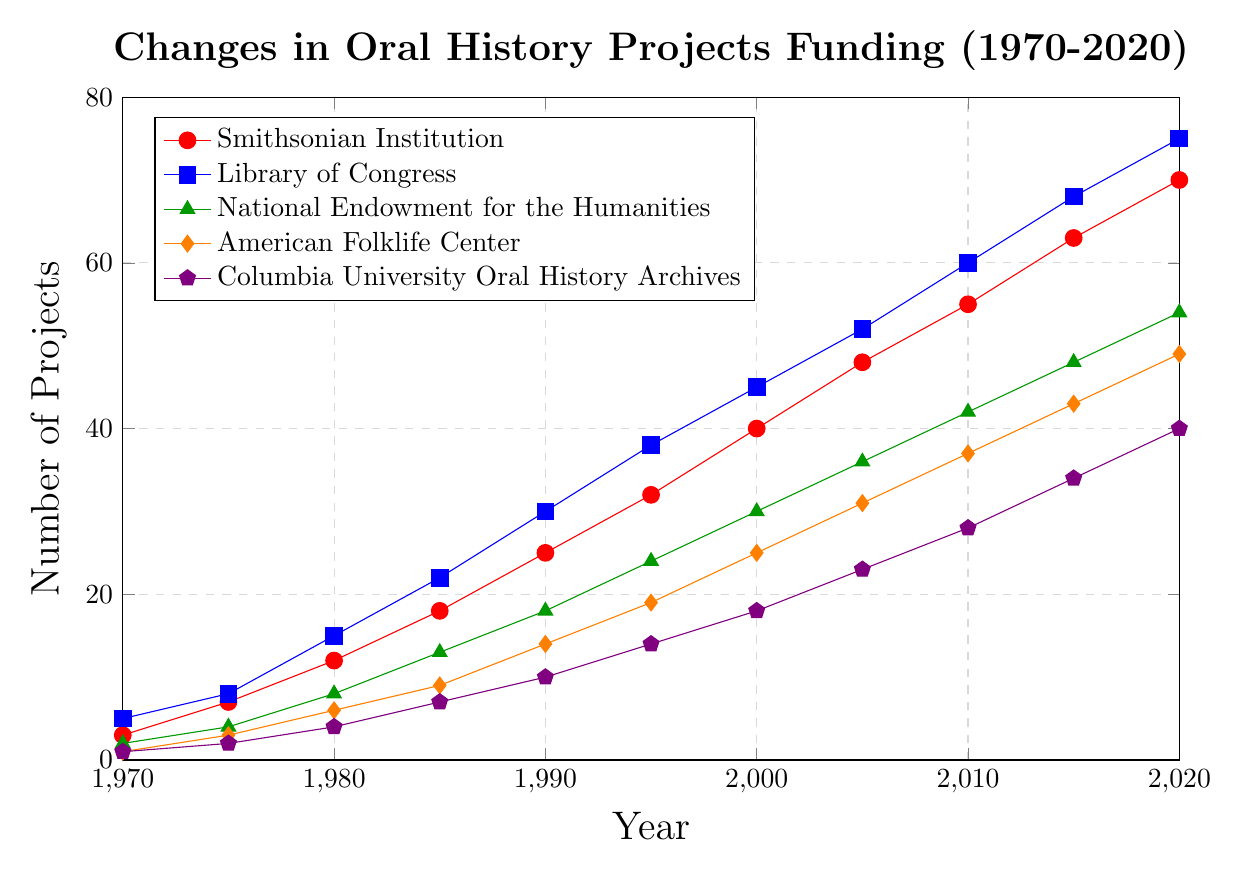How many projects did the Smithsonian Institution fund in 1985? Referring to the red line for the Smithsonian Institution in 1985, it intersects the y-axis at 18.
Answer: 18 Which institution funded the most projects in 2020? By observing the endpoints of the lines in 2020, the blue line for the Library of Congress is the highest, intersecting at 75.
Answer: Library of Congress What is the average number of projects funded by the National Endowment for the Humanities from 1970 to 2020? Adding the values for the National Endowment for the Humanities over the years (2 + 4 + 8 + 13 + 18 + 24 + 30 + 36 + 42 + 48 + 54) equals 279. Dividing this sum by the 11 data points results in an average of 279/11.
Answer: 25.36 Compare the trends between the Smithsonian Institution and Columbia University Oral History Archives. Which institution saw faster growth? By examining the slopes of both lines, it's evident that the Smithsonian Institution (red line) has a steeper slope, showing quicker growth compared to Columbia University Oral History Archives (violet line).
Answer: Smithsonian Institution In which year did the American Folklife Center and Columbia University Oral History Archives fund an equal number of projects? Observing the points where the orange and violet lines intersect, they coincide at approximately 1990, both at 10 projects.
Answer: 1990 What is the difference in the number of projects funded by the Library of Congress and the American Folklife Center in 2005? In 2005, the Library of Congress funded 52 projects (blue line), and the American Folklife Center funded 31 projects (orange line). The difference is 52 - 31.
Answer: 21 Which institution consistently funded the fewest projects between 1970 and 2020? The Columbia University Oral History Archives (violet line) occupies the lowest position on the graph consistently across all years.
Answer: Columbia University Oral History Archives Is the number of projects funded by the Smithsonian Institution in 2015 more or less than the number of projects funded by the National Endowment for the Humanities in 2020? In 2015, the Smithsonian Institution funded 63 projects (red line), whereas the National Endowment for the Humanities funded 54 projects (green line) in 2020. 63 is greater than 54.
Answer: More By how much did the number of projects funded by the Library of Congress increase from 1970 to 2020? In 1970, the Library of Congress funded 5 projects (blue line), and in 2020, it funded 75 projects (blue line). The increase is 75 - 5.
Answer: 70 How many total projects were funded by the institutions combined in 1980? Summing the projects for each institution: 12 (Smithsonian Institution) + 15 (Library of Congress) + 8 (National Endowment for the Humanities) + 6 (American Folklife Center) + 4 (Columbia University Oral History Archives). Total is 12 + 15 + 8 + 6 + 4.
Answer: 45 